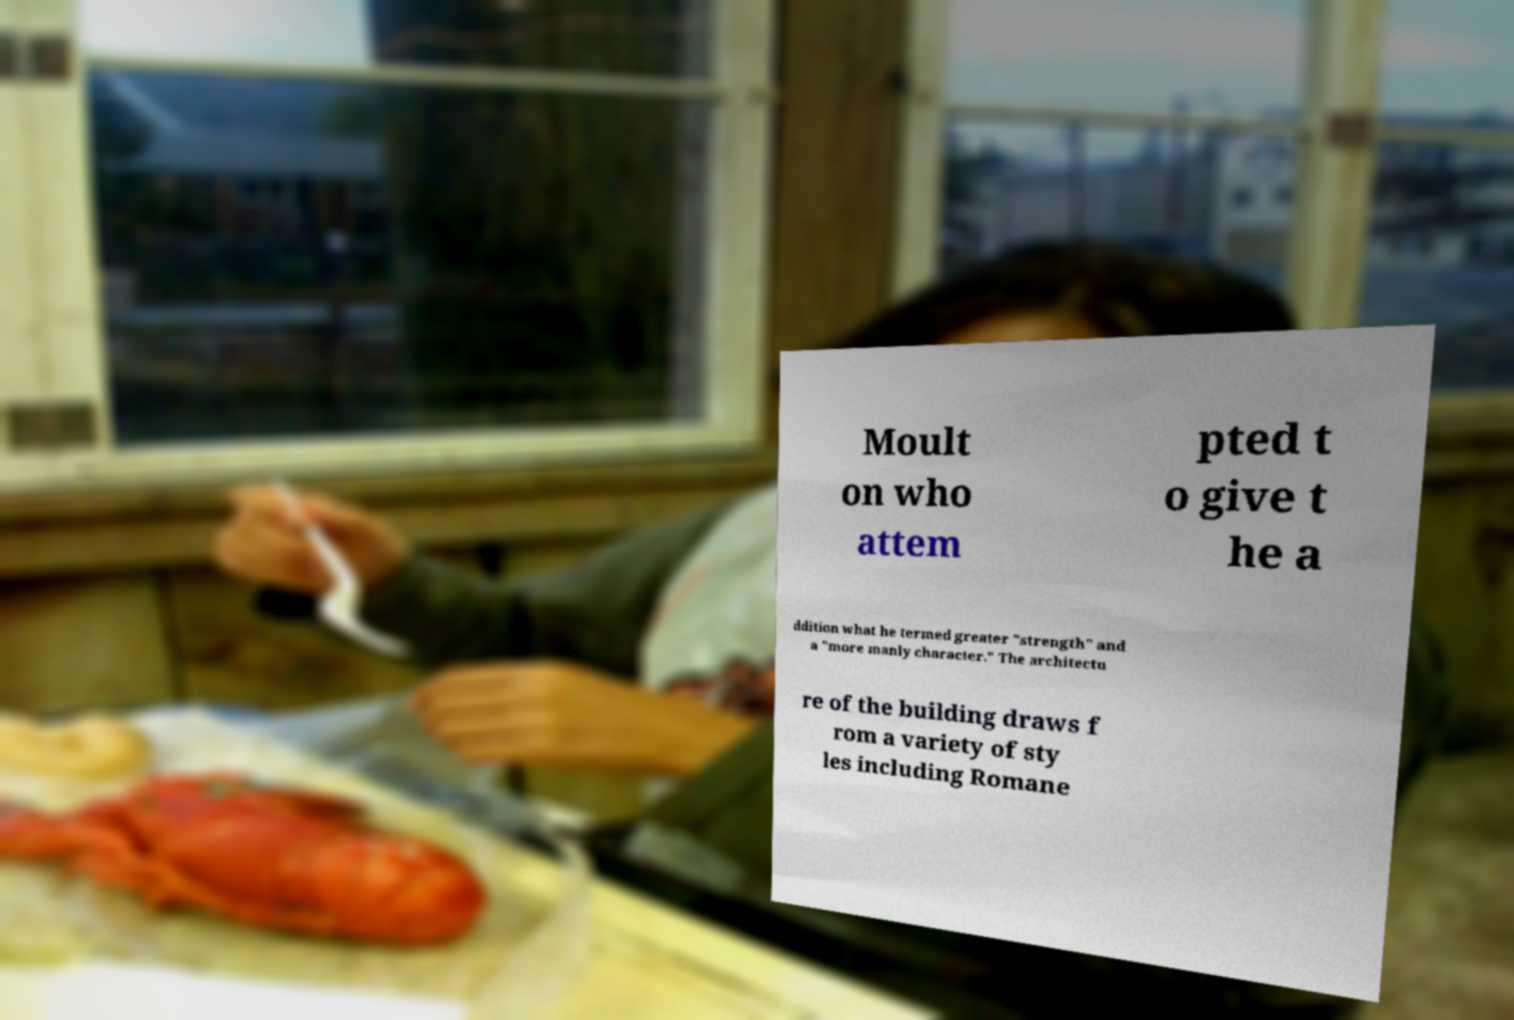Can you accurately transcribe the text from the provided image for me? Moult on who attem pted t o give t he a ddition what he termed greater "strength" and a "more manly character." The architectu re of the building draws f rom a variety of sty les including Romane 